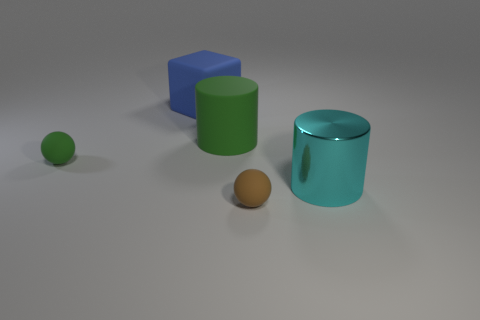Do the green rubber object left of the blue rubber block and the brown rubber sphere have the same size?
Your response must be concise. Yes. The ball that is the same color as the big rubber cylinder is what size?
Ensure brevity in your answer.  Small. Are there any other objects of the same size as the cyan object?
Offer a terse response. Yes. There is a tiny thing in front of the tiny green ball; is its color the same as the ball on the left side of the blue object?
Offer a terse response. No. Are there any other cylinders that have the same color as the matte cylinder?
Provide a succinct answer. No. How many other things are there of the same shape as the blue thing?
Keep it short and to the point. 0. There is a tiny thing that is left of the blue block; what is its shape?
Your answer should be compact. Sphere. Do the metal thing and the thing that is behind the matte cylinder have the same shape?
Provide a succinct answer. No. How big is the thing that is behind the brown object and right of the large green thing?
Make the answer very short. Large. What is the color of the large thing that is both in front of the blue matte thing and behind the metal cylinder?
Your response must be concise. Green. 